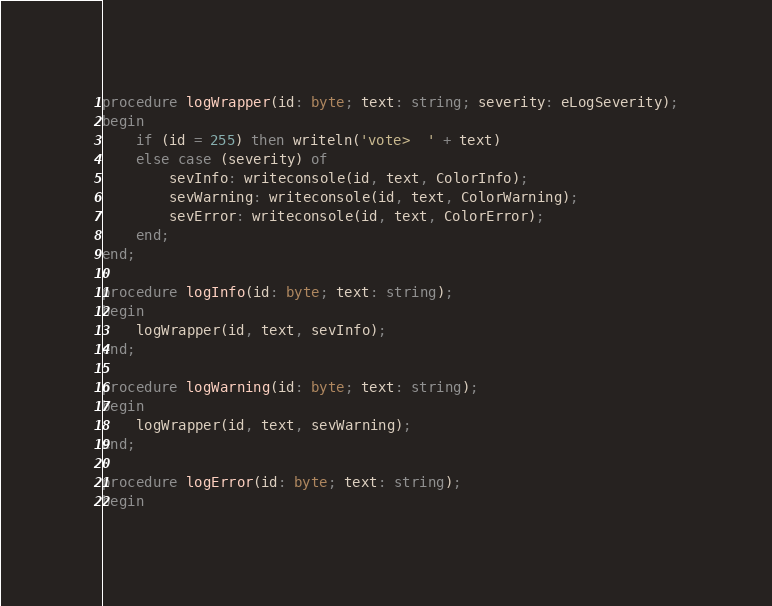Convert code to text. <code><loc_0><loc_0><loc_500><loc_500><_Pascal_>procedure logWrapper(id: byte; text: string; severity: eLogSeverity);
begin
    if (id = 255) then writeln('vote>  ' + text)
    else case (severity) of
        sevInfo: writeconsole(id, text, ColorInfo);
        sevWarning: writeconsole(id, text, ColorWarning);
        sevError: writeconsole(id, text, ColorError);
    end;
end;

procedure logInfo(id: byte; text: string);
begin
    logWrapper(id, text, sevInfo);
end;

procedure logWarning(id: byte; text: string);
begin
    logWrapper(id, text, sevWarning);
end;

procedure logError(id: byte; text: string);
begin</code> 